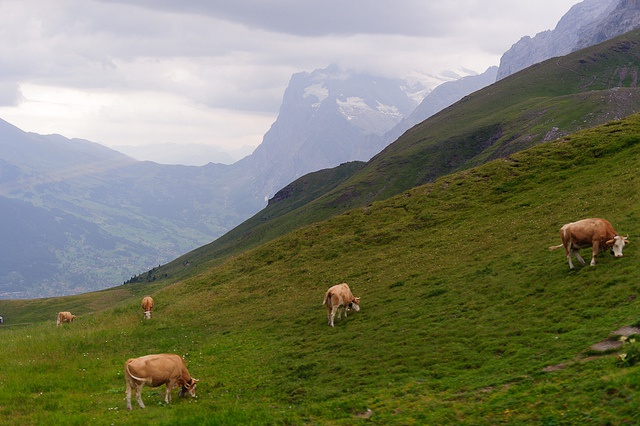Describe the objects in this image and their specific colors. I can see cow in lightgray, olive, brown, gray, and maroon tones, cow in lightgray, black, maroon, and brown tones, cow in lightgray, maroon, gray, and tan tones, cow in lightgray, olive, brown, maroon, and gray tones, and cow in lightgray, olive, brown, gray, and tan tones in this image. 